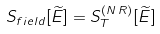<formula> <loc_0><loc_0><loc_500><loc_500>S _ { f i e l d } [ \widetilde { E } ] = S _ { T } ^ { ( N \, R ) } [ \widetilde { E } ]</formula> 